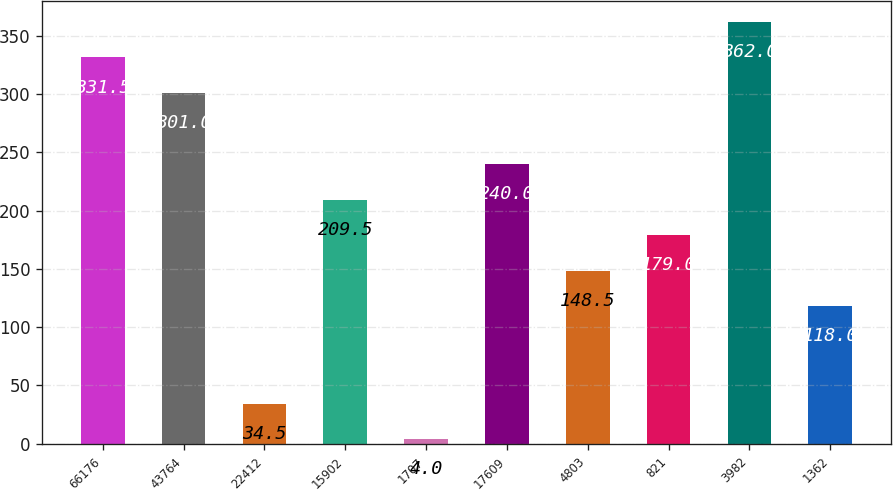Convert chart. <chart><loc_0><loc_0><loc_500><loc_500><bar_chart><fcel>66176<fcel>43764<fcel>22412<fcel>15902<fcel>1707<fcel>17609<fcel>4803<fcel>821<fcel>3982<fcel>1362<nl><fcel>331.5<fcel>301<fcel>34.5<fcel>209.5<fcel>4<fcel>240<fcel>148.5<fcel>179<fcel>362<fcel>118<nl></chart> 